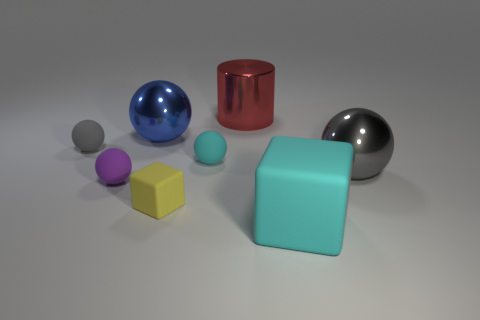There is a gray ball to the left of the cyan block; does it have the same size as the cyan object right of the big red shiny thing?
Provide a short and direct response. No. Is there a tiny cyan thing that has the same shape as the large blue shiny thing?
Provide a short and direct response. Yes. Are there an equal number of tiny objects behind the small gray matte object and large cyan things?
Ensure brevity in your answer.  No. Is the size of the purple thing the same as the gray thing that is right of the big metallic cylinder?
Your answer should be very brief. No. How many large objects are the same material as the blue ball?
Ensure brevity in your answer.  2. Is the size of the red cylinder the same as the blue ball?
Provide a short and direct response. Yes. Are there any other things that have the same color as the cylinder?
Offer a very short reply. No. There is a large thing that is both to the right of the large blue metallic thing and behind the gray rubber sphere; what is its shape?
Give a very brief answer. Cylinder. There is a thing that is behind the big blue shiny sphere; how big is it?
Make the answer very short. Large. There is a gray thing that is to the left of the metal ball that is on the right side of the small yellow block; what number of small matte balls are in front of it?
Give a very brief answer. 2. 